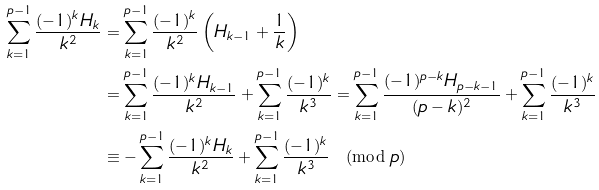<formula> <loc_0><loc_0><loc_500><loc_500>\sum _ { k = 1 } ^ { p - 1 } \frac { ( - 1 ) ^ { k } H _ { k } } { k ^ { 2 } } & = \sum _ { k = 1 } ^ { p - 1 } \frac { ( - 1 ) ^ { k } } { k ^ { 2 } } \left ( H _ { k - 1 } + \frac { 1 } { k } \right ) \\ & = \sum _ { k = 1 } ^ { p - 1 } \frac { ( - 1 ) ^ { k } H _ { k - 1 } } { k ^ { 2 } } + \sum _ { k = 1 } ^ { p - 1 } \frac { ( - 1 ) ^ { k } } { k ^ { 3 } } = \sum _ { k = 1 } ^ { p - 1 } \frac { ( - 1 ) ^ { p - k } H _ { p - k - 1 } } { ( p - k ) ^ { 2 } } + \sum _ { k = 1 } ^ { p - 1 } \frac { ( - 1 ) ^ { k } } { k ^ { 3 } } \\ & \equiv - \sum _ { k = 1 } ^ { p - 1 } \frac { ( - 1 ) ^ { k } H _ { k } } { k ^ { 2 } } + \sum _ { k = 1 } ^ { p - 1 } \frac { ( - 1 ) ^ { k } } { k ^ { 3 } } \pmod { p }</formula> 